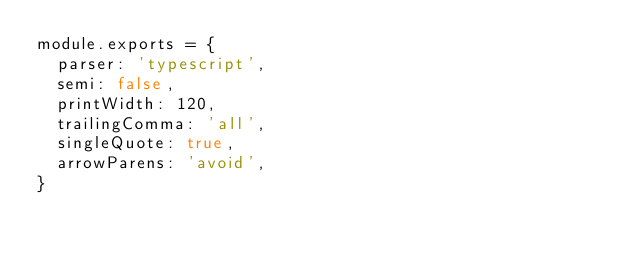Convert code to text. <code><loc_0><loc_0><loc_500><loc_500><_JavaScript_>module.exports = {
  parser: 'typescript',
  semi: false,
  printWidth: 120,
  trailingComma: 'all',
  singleQuote: true,
  arrowParens: 'avoid',
}
</code> 